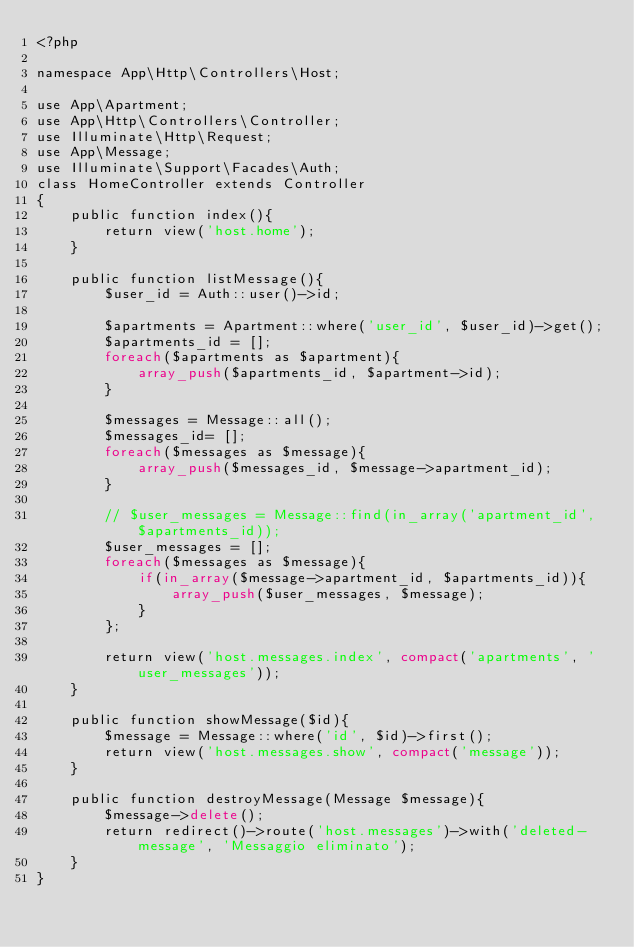Convert code to text. <code><loc_0><loc_0><loc_500><loc_500><_PHP_><?php

namespace App\Http\Controllers\Host;

use App\Apartment;
use App\Http\Controllers\Controller;
use Illuminate\Http\Request;
use App\Message;
use Illuminate\Support\Facades\Auth;
class HomeController extends Controller
{
    public function index(){
        return view('host.home');
    }

    public function listMessage(){
        $user_id = Auth::user()->id;

        $apartments = Apartment::where('user_id', $user_id)->get();
        $apartments_id = [];
        foreach($apartments as $apartment){
            array_push($apartments_id, $apartment->id);
        }

        $messages = Message::all();
        $messages_id= [];
        foreach($messages as $message){
            array_push($messages_id, $message->apartment_id);
        }

        // $user_messages = Message::find(in_array('apartment_id', $apartments_id));
        $user_messages = [];
        foreach($messages as $message){
            if(in_array($message->apartment_id, $apartments_id)){
                array_push($user_messages, $message);
            }
        };

        return view('host.messages.index', compact('apartments', 'user_messages'));
    }

    public function showMessage($id){
        $message = Message::where('id', $id)->first();
        return view('host.messages.show', compact('message'));
    }

    public function destroyMessage(Message $message){
        $message->delete();
        return redirect()->route('host.messages')->with('deleted-message', 'Messaggio eliminato');
    }
}
</code> 